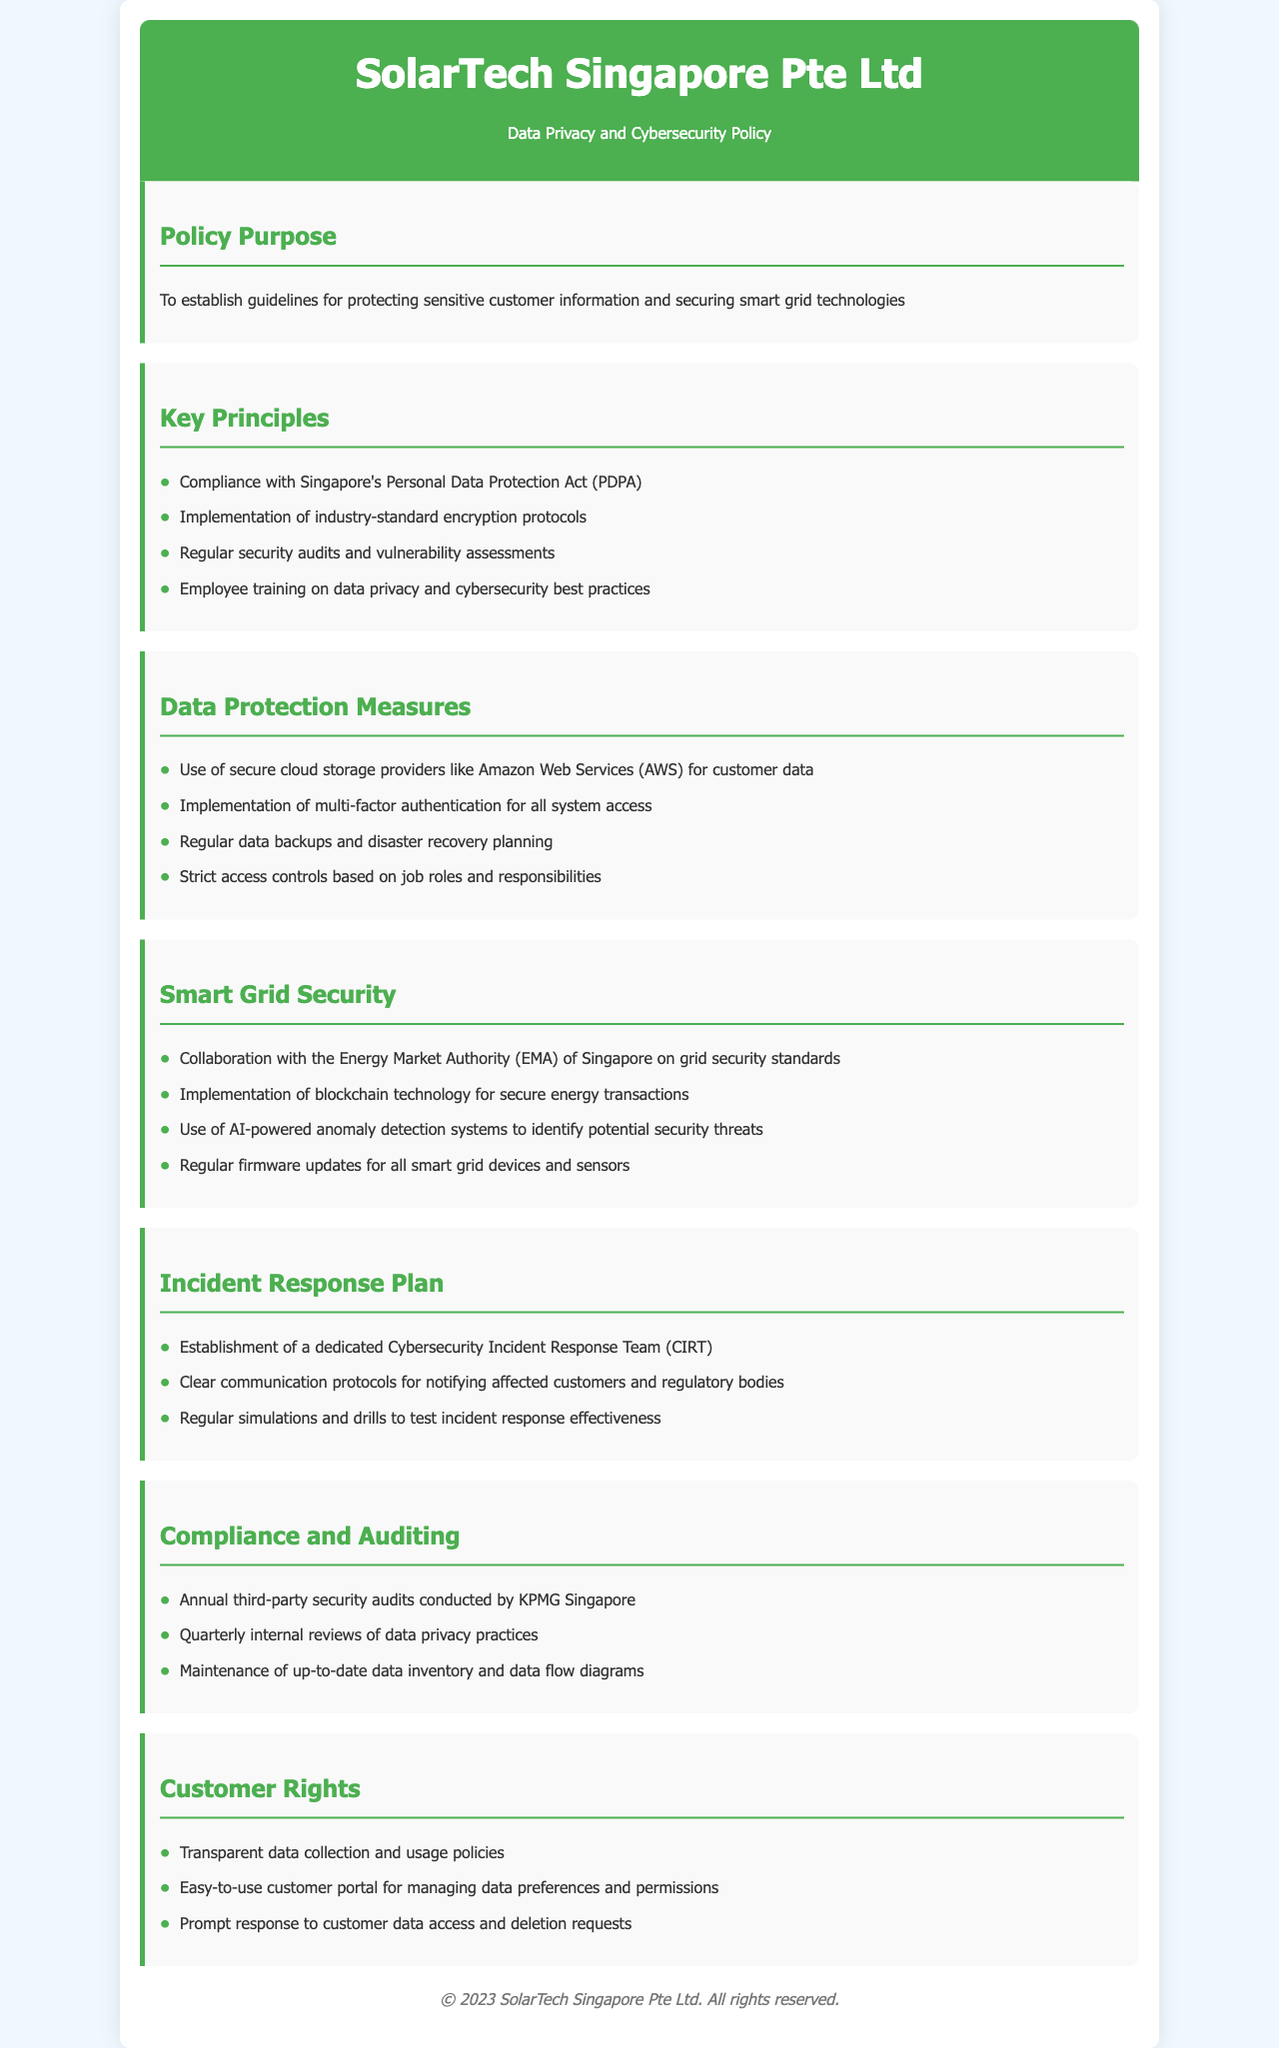What is the purpose of the policy? The purpose of the policy is to establish guidelines for protecting sensitive customer information and securing smart grid technologies.
Answer: To establish guidelines for protecting sensitive customer information and securing smart grid technologies What legislation does the policy comply with? The policy mentions compliance with Singapore's Personal Data Protection Act (PDPA).
Answer: Singapore's Personal Data Protection Act (PDPA) What security technology is mentioned for energy transactions? The document outlines the implementation of blockchain technology for secure energy transactions.
Answer: Blockchain technology How often are third-party security audits conducted? The policy states that annual third-party security audits are conducted by KPMG Singapore.
Answer: Annual What type of training is provided to employees? Employee training on data privacy and cybersecurity best practices is highlighted in the policy.
Answer: Data privacy and cybersecurity best practices What is the main communication protocol for incident response? The clear communication protocols for notifying affected customers and regulatory bodies are emphasized in the incident response plan.
Answer: Clear communication protocols Who collaborates on grid security standards? The policy specifies collaboration with the Energy Market Authority (EMA) of Singapore.
Answer: Energy Market Authority (EMA) What is implemented for system access security? The policy states that multi-factor authentication is implemented for all system access.
Answer: Multi-factor authentication What rights do customers have regarding data? The policy mentions that customers have transparent data collection and usage policies among other rights.
Answer: Transparent data collection and usage policies 